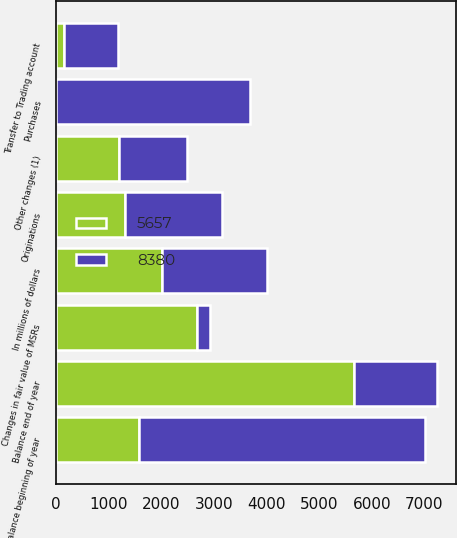Convert chart. <chart><loc_0><loc_0><loc_500><loc_500><stacked_bar_chart><ecel><fcel>In millions of dollars<fcel>Balance beginning of year<fcel>Originations<fcel>Purchases<fcel>Changes in fair value of MSRs<fcel>Transfer to Trading account<fcel>Other changes (1)<fcel>Balance end of year<nl><fcel>5657<fcel>2008<fcel>1577<fcel>1311<fcel>1<fcel>2682<fcel>163<fcel>1190<fcel>5657<nl><fcel>8380<fcel>2007<fcel>5439<fcel>1843<fcel>3678<fcel>247<fcel>1026<fcel>1307<fcel>1577<nl></chart> 